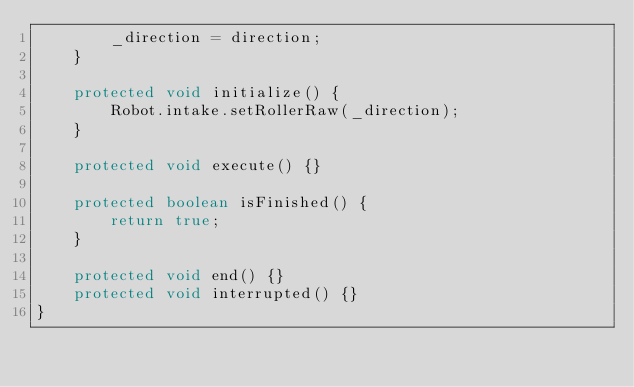<code> <loc_0><loc_0><loc_500><loc_500><_Java_>        _direction = direction;
    }
    
    protected void initialize() {
        Robot.intake.setRollerRaw(_direction);
    }
    
    protected void execute() {}
    
    protected boolean isFinished() {
        return true;
    }
    
    protected void end() {}
    protected void interrupted() {}
}

</code> 